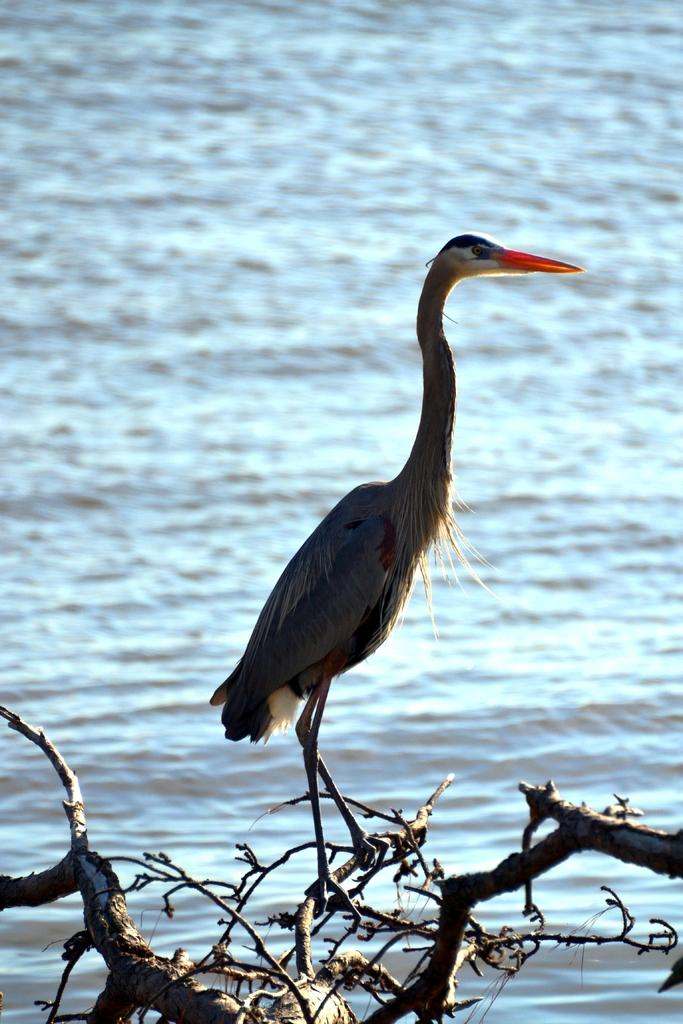What type of animal can be seen in the image? There is a water bird in the image. Where is the water bird located? The water bird is on a branch of a tree. What can be seen in the background of the image? There is water visible in the image. What type of current is flowing through the pet in the image? There is no pet present in the image, and therefore no current can be flowing through it. 